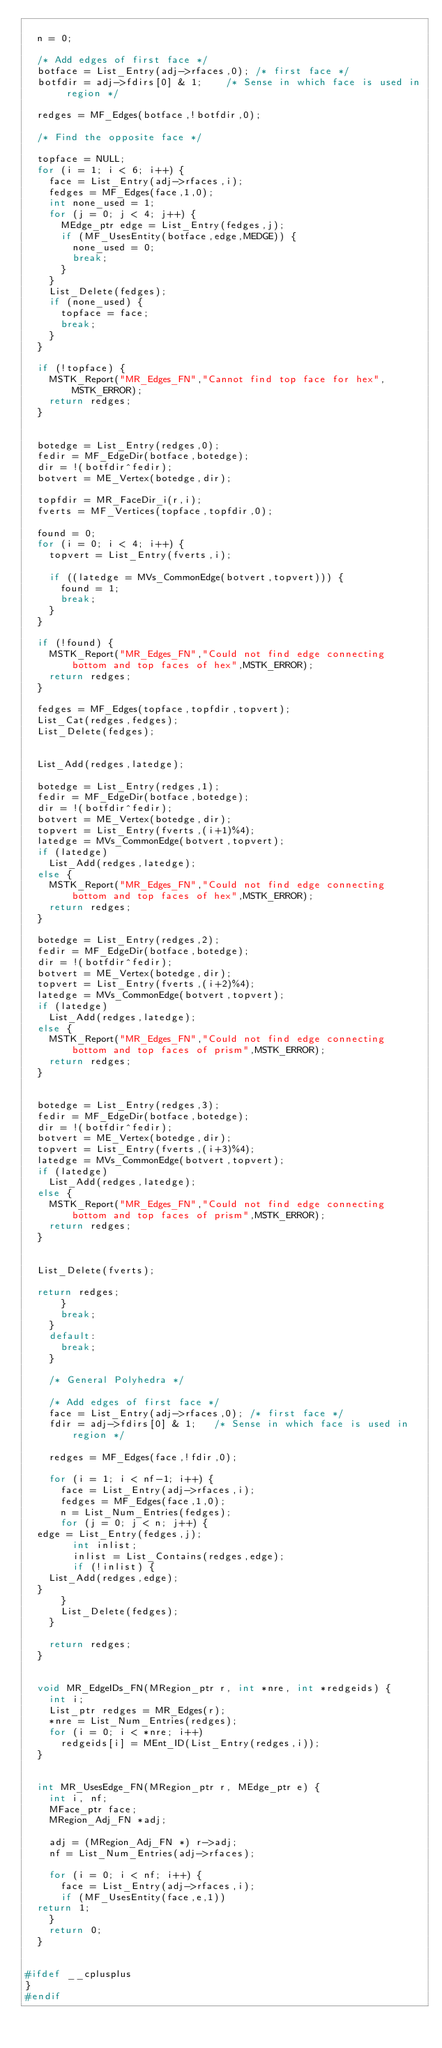Convert code to text. <code><loc_0><loc_0><loc_500><loc_500><_C_>
	n = 0;
	
	/* Add edges of first face */
	botface = List_Entry(adj->rfaces,0); /* first face */
	botfdir = adj->fdirs[0] & 1;    /* Sense in which face is used in region */
	
	redges = MF_Edges(botface,!botfdir,0);

	/* Find the opposite face */

	topface = NULL;
	for (i = 1; i < 6; i++) {
	  face = List_Entry(adj->rfaces,i);
	  fedges = MF_Edges(face,1,0);
	  int none_used = 1;
	  for (j = 0; j < 4; j++) {
	    MEdge_ptr edge = List_Entry(fedges,j);
	    if (MF_UsesEntity(botface,edge,MEDGE)) {
	      none_used = 0;
	      break;
	    }
	  }
	  List_Delete(fedges);
	  if (none_used) {
	    topface = face;
	    break;
	  }
	}

	if (!topface) {
	  MSTK_Report("MR_Edges_FN","Cannot find top face for hex",MSTK_ERROR);
	  return redges;
	}
	

	botedge = List_Entry(redges,0);
	fedir = MF_EdgeDir(botface,botedge);
	dir = !(botfdir^fedir);
	botvert = ME_Vertex(botedge,dir); 

	topfdir = MR_FaceDir_i(r,i);
	fverts = MF_Vertices(topface,topfdir,0);

	found = 0;
	for (i = 0; i < 4; i++) {
	  topvert = List_Entry(fverts,i);

	  if ((latedge = MVs_CommonEdge(botvert,topvert))) {
	    found = 1;
	    break;
	  }
	}

	if (!found) {
	  MSTK_Report("MR_Edges_FN","Could not find edge connecting bottom and top faces of hex",MSTK_ERROR);
	  return redges;
	}

	fedges = MF_Edges(topface,topfdir,topvert);
	List_Cat(redges,fedges);
	List_Delete(fedges);


	List_Add(redges,latedge);

	botedge = List_Entry(redges,1);
	fedir = MF_EdgeDir(botface,botedge);
	dir = !(botfdir^fedir);
	botvert = ME_Vertex(botedge,dir);
	topvert = List_Entry(fverts,(i+1)%4);
	latedge = MVs_CommonEdge(botvert,topvert);
	if (latedge)
	  List_Add(redges,latedge);
	else {
	  MSTK_Report("MR_Edges_FN","Could not find edge connecting bottom and top faces of hex",MSTK_ERROR);
	  return redges;
	}

	botedge = List_Entry(redges,2);
	fedir = MF_EdgeDir(botface,botedge);
	dir = !(botfdir^fedir);
	botvert = ME_Vertex(botedge,dir);
	topvert = List_Entry(fverts,(i+2)%4);
	latedge = MVs_CommonEdge(botvert,topvert);
	if (latedge)
	  List_Add(redges,latedge);
	else {
	  MSTK_Report("MR_Edges_FN","Could not find edge connecting bottom and top faces of prism",MSTK_ERROR);
	  return redges;
	}


	botedge = List_Entry(redges,3);
	fedir = MF_EdgeDir(botface,botedge);
	dir = !(botfdir^fedir);
	botvert = ME_Vertex(botedge,dir);
	topvert = List_Entry(fverts,(i+3)%4);
	latedge = MVs_CommonEdge(botvert,topvert);
	if (latedge)
	  List_Add(redges,latedge);
	else {
	  MSTK_Report("MR_Edges_FN","Could not find edge connecting bottom and top faces of prism",MSTK_ERROR);
	  return redges;
	}

	
	List_Delete(fverts);

	return redges;
      }
      break;
    }
    default:
      break;
    }

    /* General Polyhedra */
    
    /* Add edges of first face */
    face = List_Entry(adj->rfaces,0); /* first face */
    fdir = adj->fdirs[0] & 1;   /* Sense in which face is used in region */
    
    redges = MF_Edges(face,!fdir,0);
    
    for (i = 1; i < nf-1; i++) {
      face = List_Entry(adj->rfaces,i);
      fedges = MF_Edges(face,1,0);
      n = List_Num_Entries(fedges);
      for (j = 0; j < n; j++) {
	edge = List_Entry(fedges,j);
        int inlist;
        inlist = List_Contains(redges,edge);
        if (!inlist) {
	  List_Add(redges,edge);
	}
      }
      List_Delete(fedges);
    }
    
    return redges;
  }


  void MR_EdgeIDs_FN(MRegion_ptr r, int *nre, int *redgeids) {
    int i;
    List_ptr redges = MR_Edges(r);
    *nre = List_Num_Entries(redges);
    for (i = 0; i < *nre; i++)
      redgeids[i] = MEnt_ID(List_Entry(redges,i));
  }


  int MR_UsesEdge_FN(MRegion_ptr r, MEdge_ptr e) {
    int i, nf;
    MFace_ptr face;
    MRegion_Adj_FN *adj;

    adj = (MRegion_Adj_FN *) r->adj;
    nf = List_Num_Entries(adj->rfaces);

    for (i = 0; i < nf; i++) {
      face = List_Entry(adj->rfaces,i);
      if (MF_UsesEntity(face,e,1))
	return 1;
    }
    return 0;
  }


#ifdef __cplusplus
}
#endif
</code> 